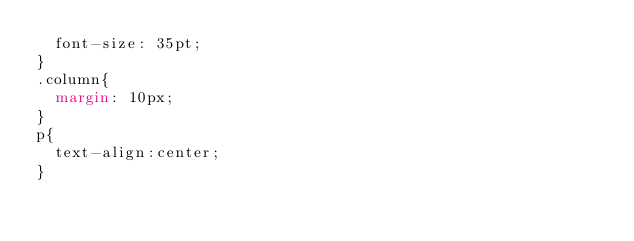Convert code to text. <code><loc_0><loc_0><loc_500><loc_500><_CSS_>  font-size: 35pt;
}
.column{
  margin: 10px;
}
p{
  text-align:center;
}
</code> 